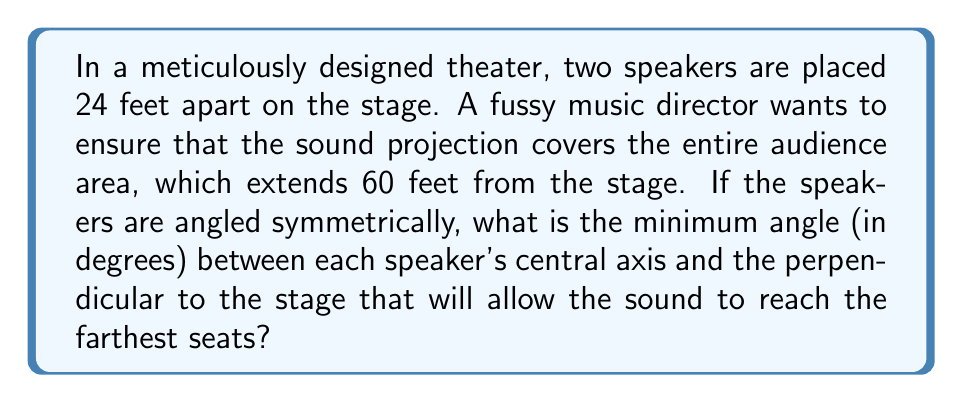Help me with this question. Let's approach this step-by-step:

1) We can visualize this problem as a right triangle, where:
   - The base is half the distance between the speakers: 24/2 = 12 feet
   - The height is the distance to the farthest seats: 60 feet

2) Let's draw this situation:

[asy]
unitsize(3px);
pair A = (0,0), B = (12,0), C = (0,60);
draw(A--B--C--A);
draw(A--(0,65), arrow=Arrow(TeXHead));
label("12 ft", (6,-5));
label("60 ft", (-5,30), W);
label("θ", (2,5), NW);
label("Speaker", A, SW);
label("Farthest seat", C, N);
[/asy]

3) We need to find the angle θ at the base of this triangle.

4) We can use the tangent function to find this angle:

   $$\tan(θ) = \frac{\text{opposite}}{\text{adjacent}} = \frac{60}{12} = 5$$

5) To get the angle, we need to take the inverse tangent (arctan or tan^(-1)):

   $$θ = \tan^{-1}(5)$$

6) Using a calculator or mathematical tables, we find:

   $$θ ≈ 78.69°$$

7) However, this is the angle from the perpendicular to the speaker's axis. The question asks for the angle between the speaker's axis and the perpendicular, which is the complement of this angle:

   $$90° - 78.69° ≈ 11.31°$$

8) Rounding to the nearest tenth of a degree for practical purposes:

   $$11.3°$$

This angle ensures that the sound from each speaker will just reach the farthest seats, providing complete coverage of the audience area.
Answer: $11.3°$ 